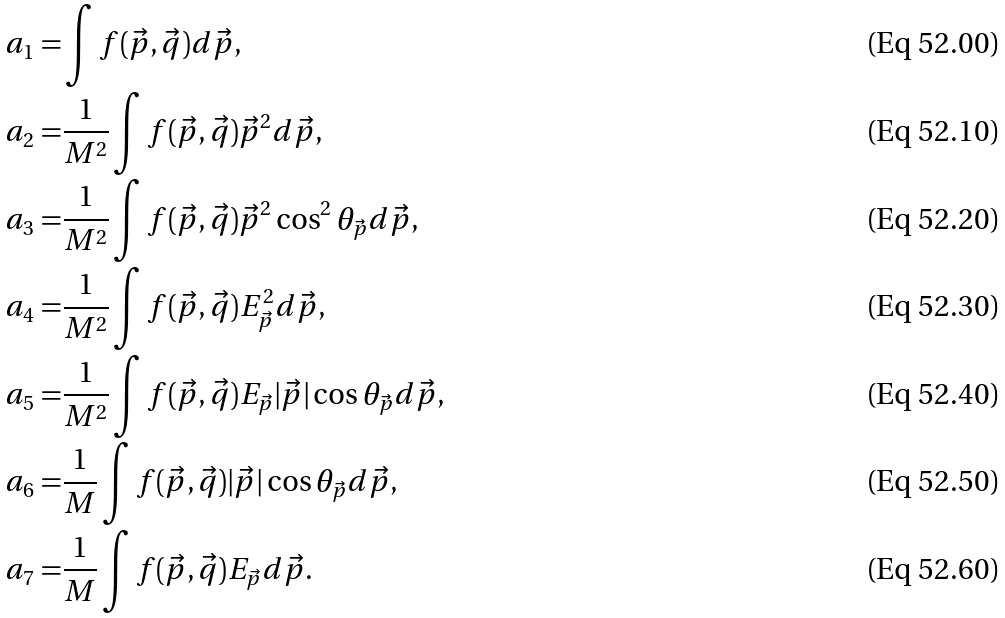<formula> <loc_0><loc_0><loc_500><loc_500>a _ { 1 } = & \int f ( \vec { p } , \vec { q } ) d \vec { p } , \\ a _ { 2 } = & \frac { 1 } { M ^ { 2 } } \int f ( \vec { p } , \vec { q } ) \vec { p } ^ { 2 } d \vec { p } , \\ a _ { 3 } = & \frac { 1 } { M ^ { 2 } } \int f ( \vec { p } , \vec { q } ) \vec { p } ^ { 2 } \cos ^ { 2 } \theta _ { \vec { p } } d \vec { p } , \\ a _ { 4 } = & \frac { 1 } { M ^ { 2 } } \int f ( \vec { p } , \vec { q } ) E _ { \vec { p } } ^ { 2 } d \vec { p } , \\ a _ { 5 } = & \frac { 1 } { M ^ { 2 } } \int f ( \vec { p } , \vec { q } ) E _ { \vec { p } } | \vec { p } | \cos \theta _ { \vec { p } } d \vec { p } , \\ a _ { 6 } = & \frac { 1 } { M } \int f ( \vec { p } , \vec { q } ) | \vec { p } | \cos \theta _ { \vec { p } } d \vec { p } , \\ a _ { 7 } = & \frac { 1 } { M } \int f ( \vec { p } , \vec { q } ) E _ { \vec { p } } d \vec { p } .</formula> 